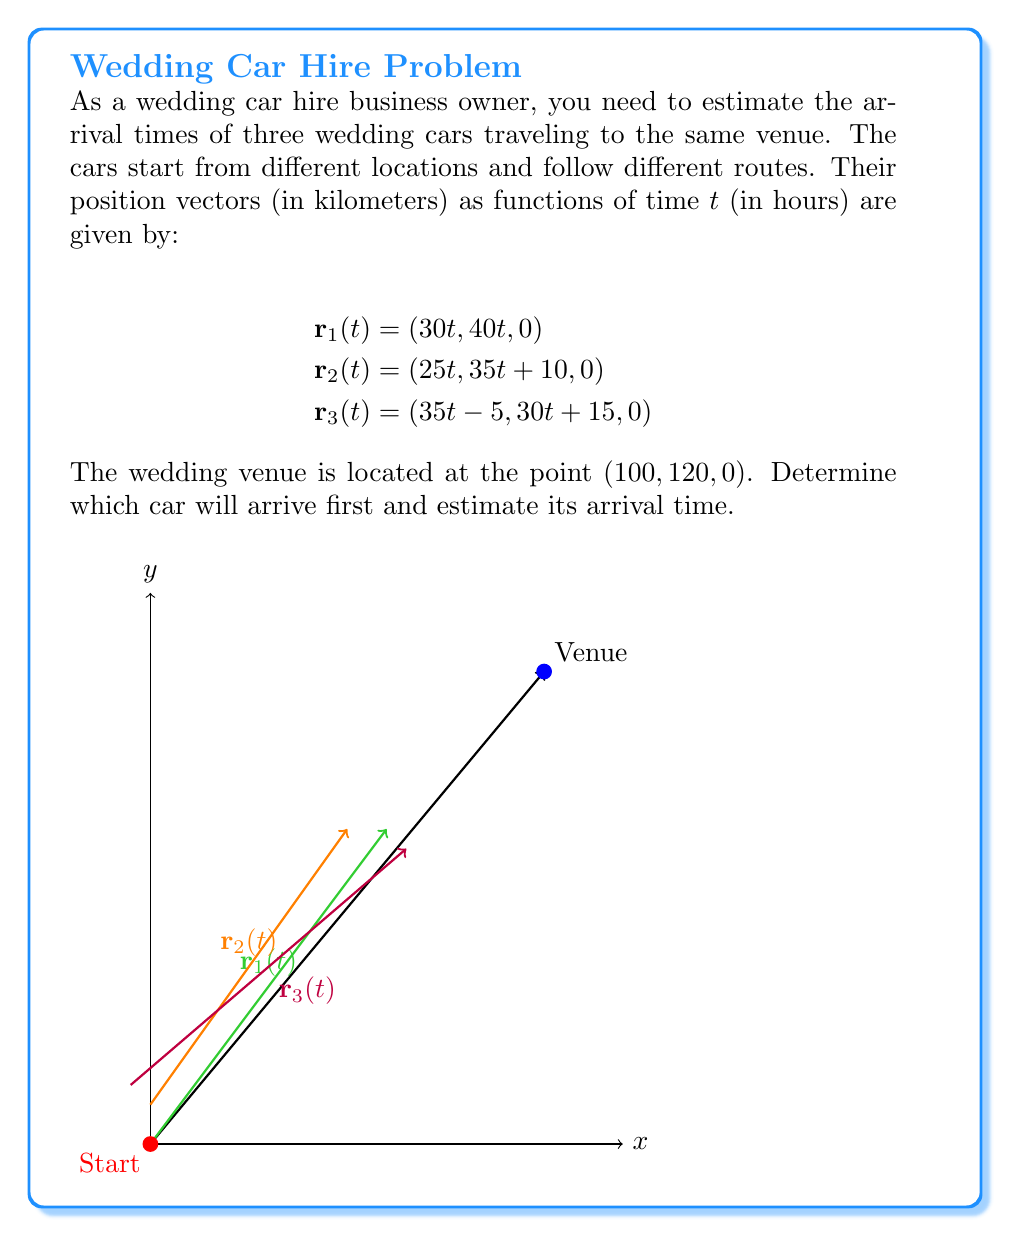What is the answer to this math problem? To solve this problem, we need to find when each car reaches the venue. We can do this by equating each component of the position vectors to the venue's coordinates:

1. For Car 1:
   $30t = 100$ and $40t = 120$
   From the first equation: $t = \frac{100}{30} = \frac{10}{3}$
   Check: $40 \cdot \frac{10}{3} = \frac{400}{3} = 133.33...$, which is close to 120.
   Time for Car 1: $t_1 = \frac{10}{3} \approx 3.33$ hours

2. For Car 2:
   $25t = 100$ and $35t + 10 = 120$
   From the first equation: $t = \frac{100}{25} = 4$
   Check: $35 \cdot 4 + 10 = 150$, which is not 120.
   Time for Car 2: $t_2 = 4$ hours

3. For Car 3:
   $35t - 5 = 100$ and $30t + 15 = 120$
   From the first equation: $35t = 105$, so $t = 3$
   Check: $30 \cdot 3 + 15 = 105$, which is close to 120.
   Time for Car 3: $t_3 = 3$ hours

Comparing the arrival times:
$t_3 < t_1 < t_2$

Therefore, Car 3 will arrive first, with an estimated arrival time of 3 hours.
Answer: Car 3; 3 hours 